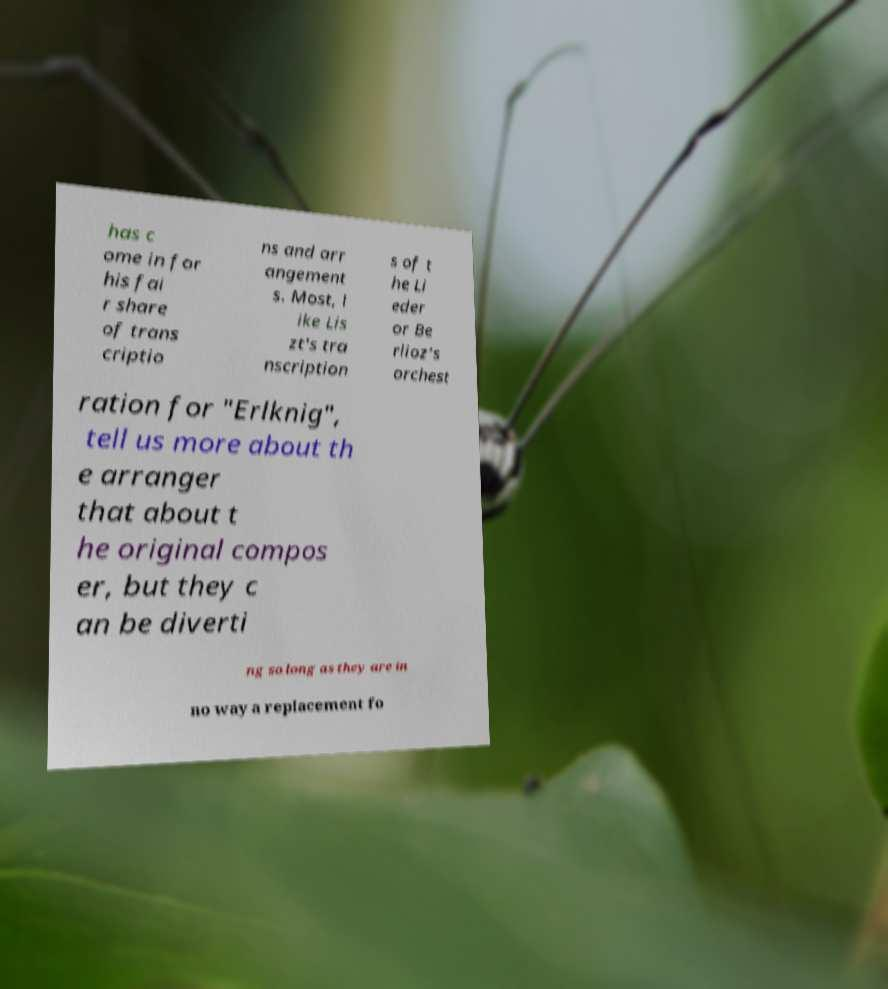What messages or text are displayed in this image? I need them in a readable, typed format. has c ome in for his fai r share of trans criptio ns and arr angement s. Most, l ike Lis zt's tra nscription s of t he Li eder or Be rlioz’s orchest ration for "Erlknig", tell us more about th e arranger that about t he original compos er, but they c an be diverti ng so long as they are in no way a replacement fo 